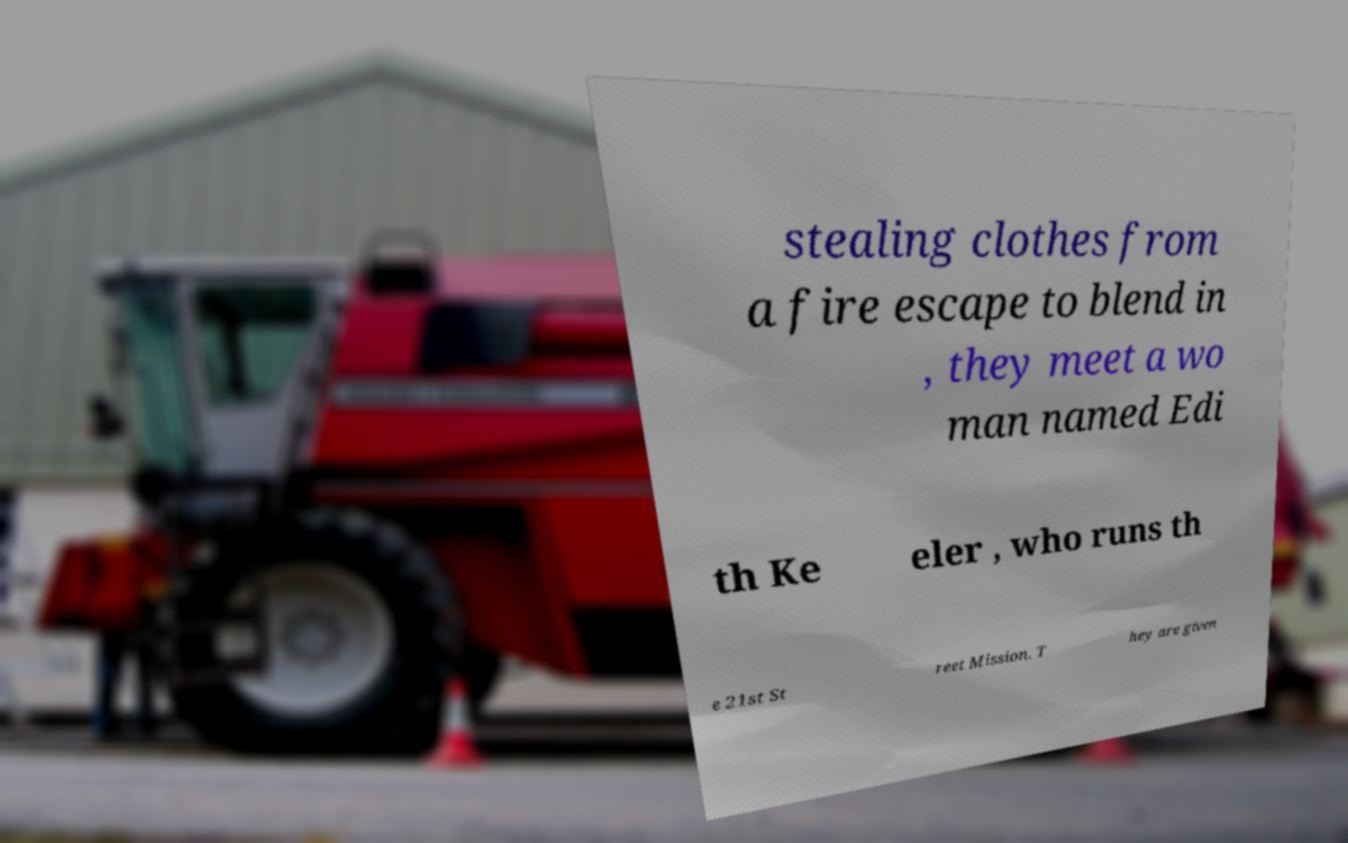I need the written content from this picture converted into text. Can you do that? stealing clothes from a fire escape to blend in , they meet a wo man named Edi th Ke eler , who runs th e 21st St reet Mission. T hey are given 